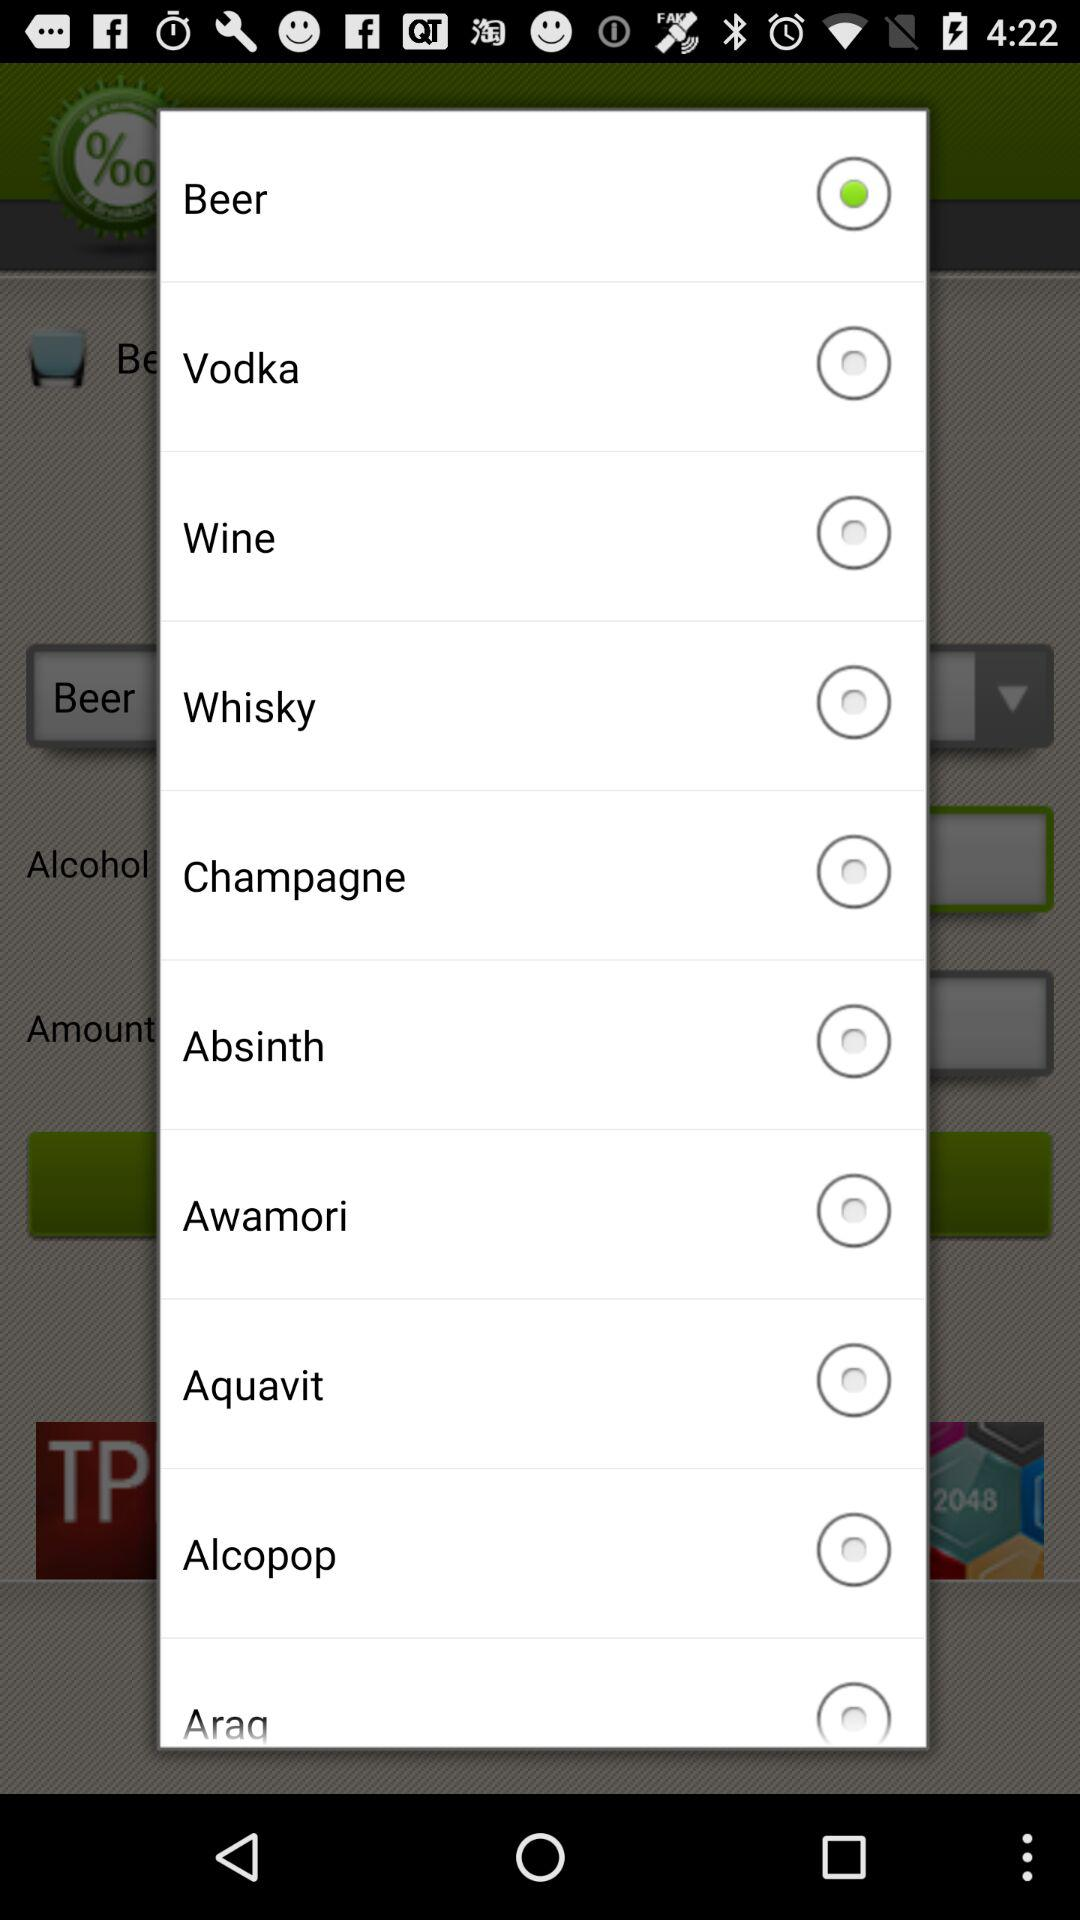Which option is selected among all? The selected option is "Beer". 